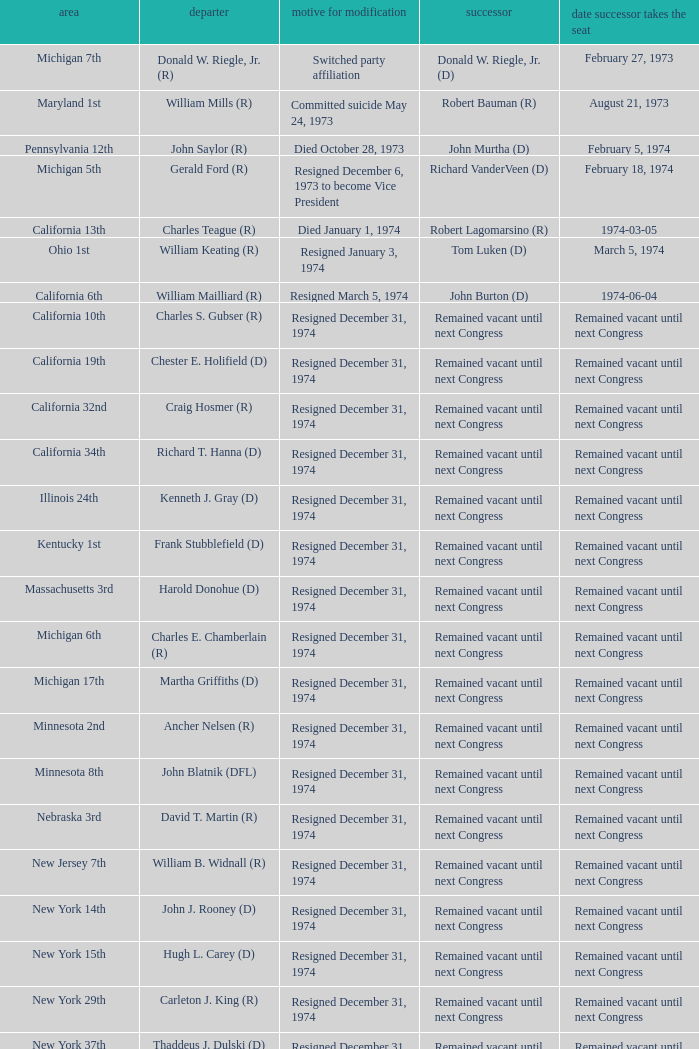What was the district when the reason for change was died January 1, 1974? California 13th. 